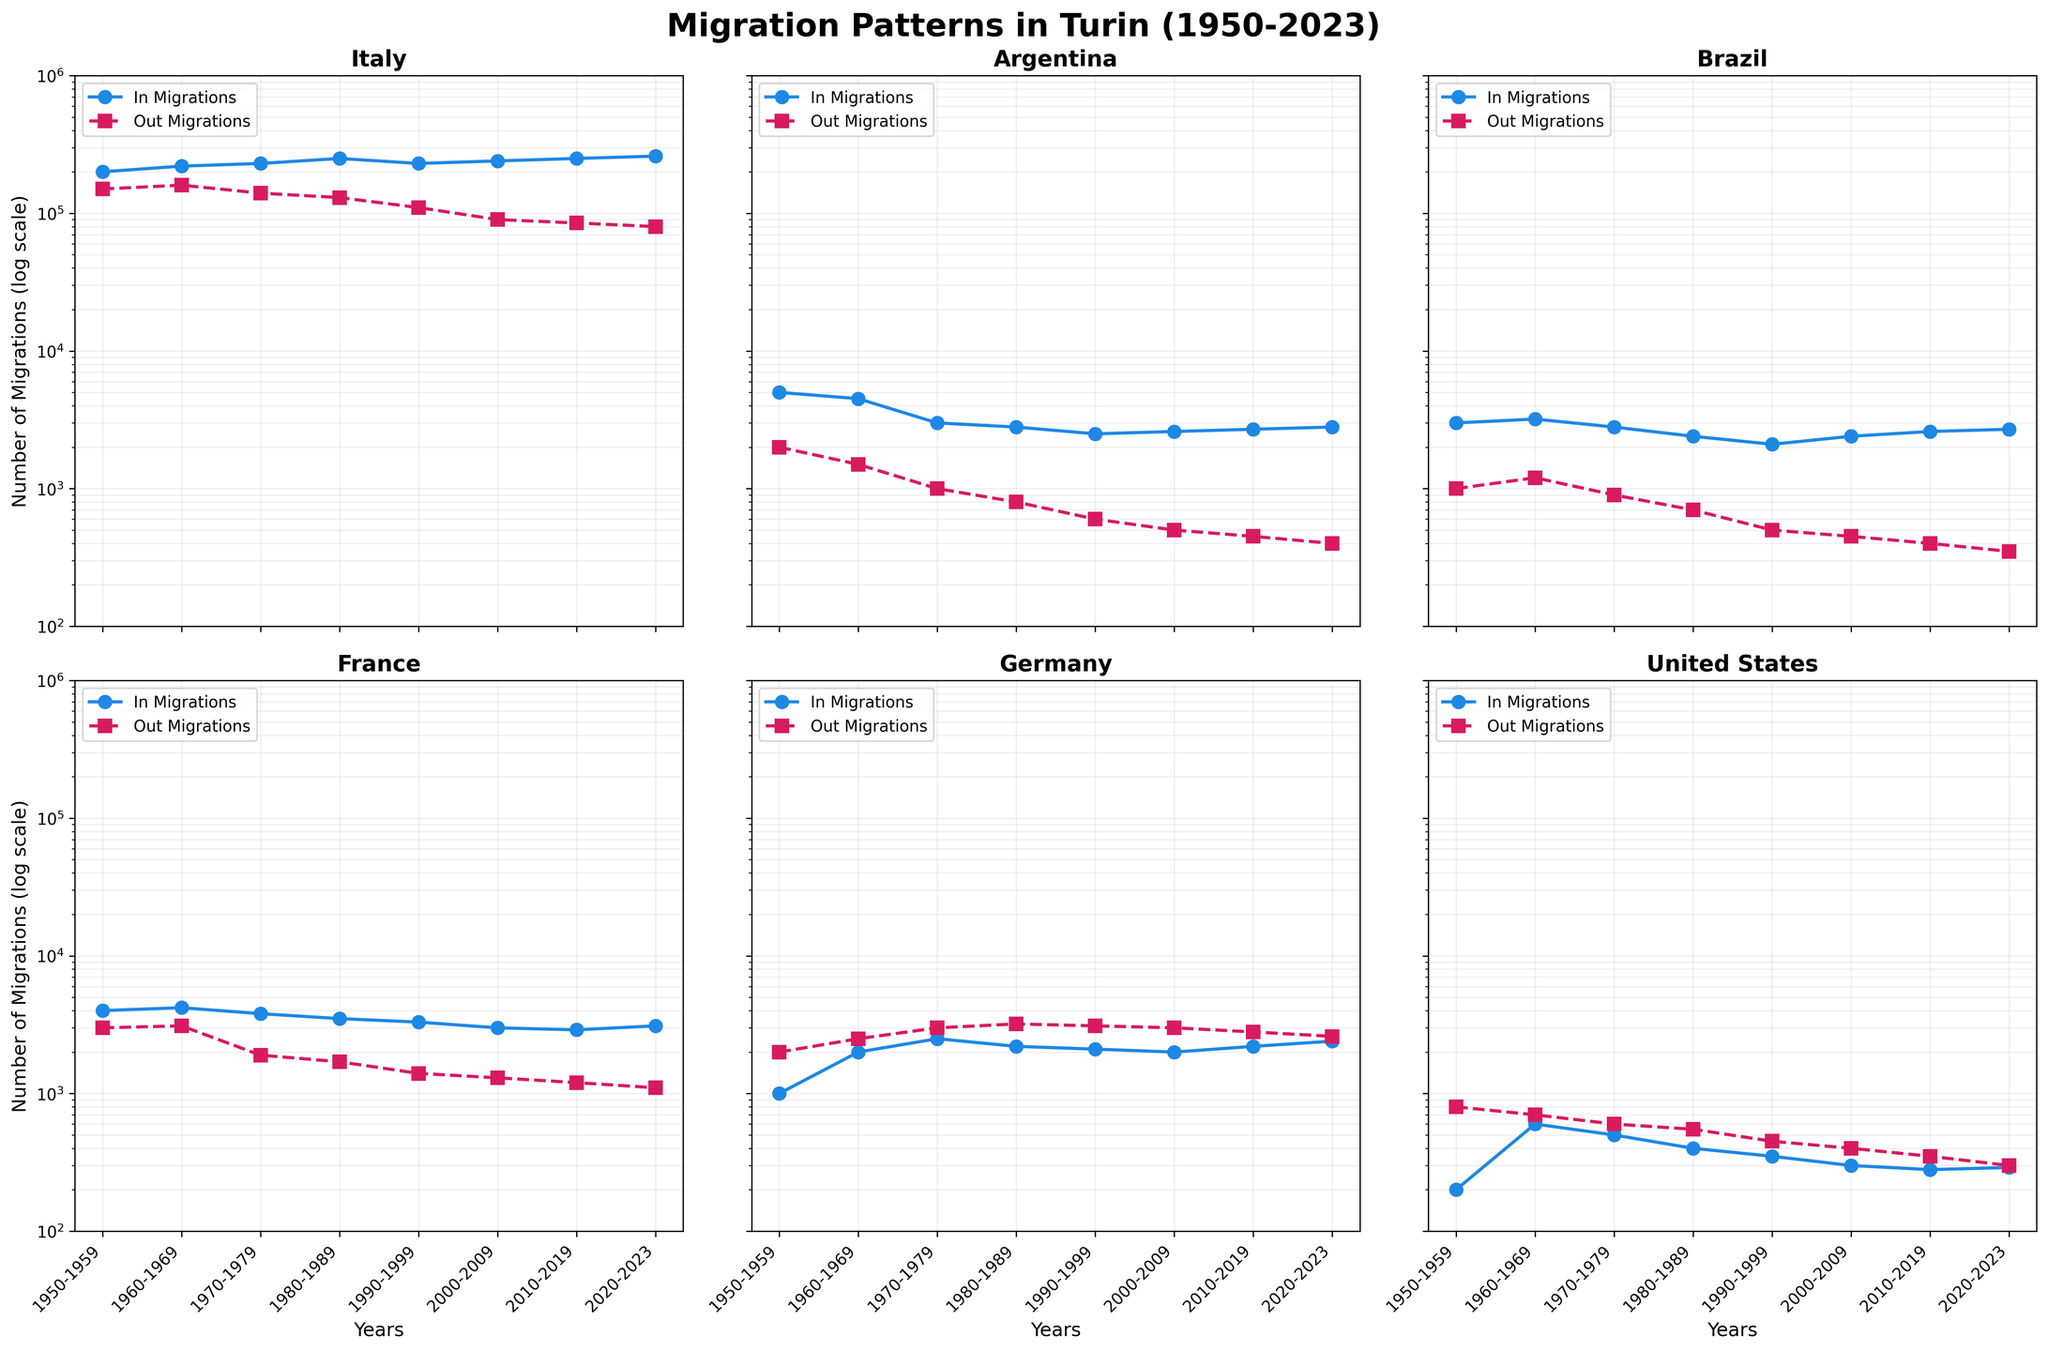What is the predominant trend for in-migrations to Turin from Italy from 1950 to 2023? Observing the Italy subplot, the in-migrations trend shows a general increase over the entire period from 1950 to 2023. The number increases steadily in each decade.
Answer: Increasing Which country shows the lowest in-migrations to Turin during the 1950s? On the 1950s' data, United States shows the lowest in-migrations to Turin with the smallest in-migration value compared to other countries.
Answer: United States In the period 2000-2009, which country experienced a higher number of out-migrations from Turin: Germany or France? Comparing the subplots for Germany and France for the period 2000-2009, the out-migration number for Germany is higher (3000) than that for France (1300).
Answer: Germany How did the in-migrations to Turin from Brazil change from the 1990s to the 2000s? Looking at the Brazil subplot, in-migrations to Turin increased slightly from 2100 in the 1990s to 2400 in the 2000s.
Answer: Increased From which country did Turin experience the greatest decline in out-migrations between 1980-1989 and 1990-1999? Observing the subplots, Italy experienced the greatest decline in out-migrations, dropping significantly from 130000 in the 1980s to 110000 in the 1990s.
Answer: Italy Which country has consistently higher in-migrations than out-migrations across all periods? By examining each subplot, it is Italy that consistently shows higher in-migrations compared to out-migrations across all periods.
Answer: Italy During which decade did Turin receive the least amount of in-migrations from Argentina? By analyzing the Argentina subplot, the decade with the least in-migrations appears to be the 1990s with 2500 in-migrations.
Answer: 1990s Which country saw the highest out-migrations from Turin in the 2010-2019 period? Based on the subplots for the 2010-2019 period, Germany experienced the highest out-migrations with 2800.
Answer: Germany What trend is evident for out-migrations to the United States from Turin over the entire period? The United States subplot indicates that out-migrations from Turin to the United States decrease progressively over the decades, from around 800 in the 1950s to 300 in the 2020s.
Answer: Decreasing 